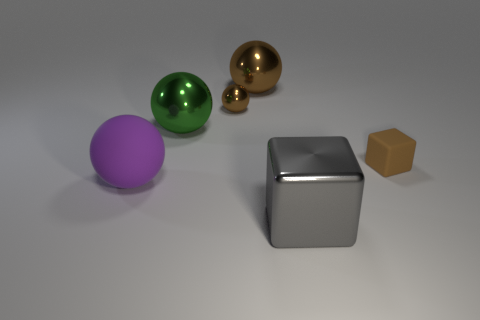Subtract 2 balls. How many balls are left? 2 Subtract all brown cubes. How many brown balls are left? 2 Subtract all purple spheres. How many spheres are left? 3 Subtract all green balls. How many balls are left? 3 Add 2 brown matte things. How many objects exist? 8 Subtract all yellow spheres. Subtract all cyan cylinders. How many spheres are left? 4 Subtract 0 yellow cubes. How many objects are left? 6 Subtract all balls. How many objects are left? 2 Subtract all metallic blocks. Subtract all tiny gray balls. How many objects are left? 5 Add 5 brown shiny objects. How many brown shiny objects are left? 7 